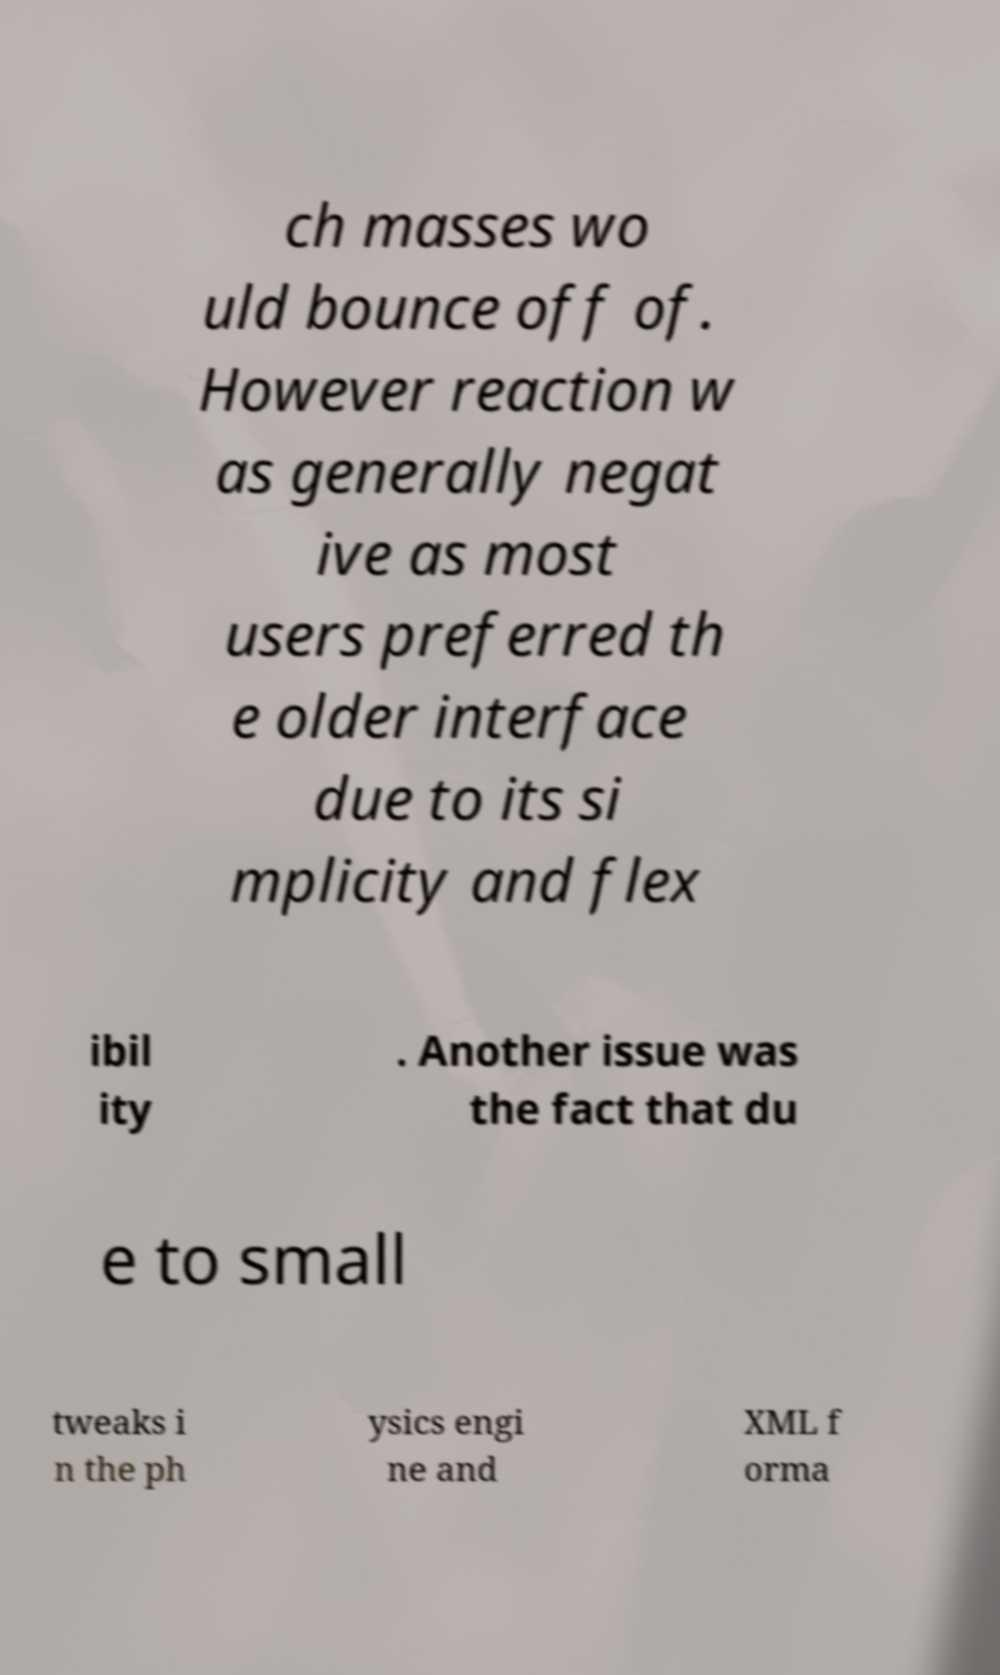Can you accurately transcribe the text from the provided image for me? ch masses wo uld bounce off of. However reaction w as generally negat ive as most users preferred th e older interface due to its si mplicity and flex ibil ity . Another issue was the fact that du e to small tweaks i n the ph ysics engi ne and XML f orma 